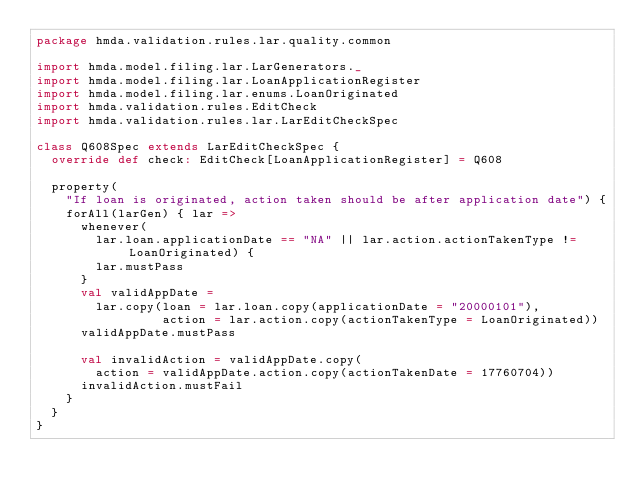<code> <loc_0><loc_0><loc_500><loc_500><_Scala_>package hmda.validation.rules.lar.quality.common

import hmda.model.filing.lar.LarGenerators._
import hmda.model.filing.lar.LoanApplicationRegister
import hmda.model.filing.lar.enums.LoanOriginated
import hmda.validation.rules.EditCheck
import hmda.validation.rules.lar.LarEditCheckSpec

class Q608Spec extends LarEditCheckSpec {
  override def check: EditCheck[LoanApplicationRegister] = Q608

  property(
    "If loan is originated, action taken should be after application date") {
    forAll(larGen) { lar =>
      whenever(
        lar.loan.applicationDate == "NA" || lar.action.actionTakenType != LoanOriginated) {
        lar.mustPass
      }
      val validAppDate =
        lar.copy(loan = lar.loan.copy(applicationDate = "20000101"),
                 action = lar.action.copy(actionTakenType = LoanOriginated))
      validAppDate.mustPass

      val invalidAction = validAppDate.copy(
        action = validAppDate.action.copy(actionTakenDate = 17760704))
      invalidAction.mustFail
    }
  }
}
</code> 